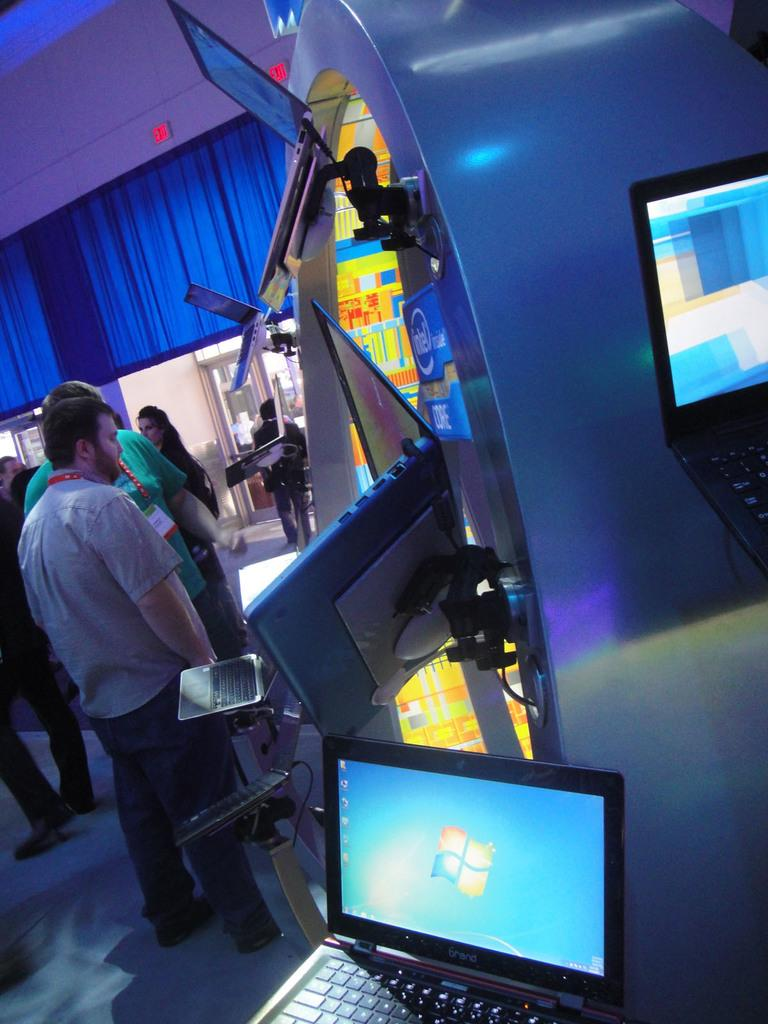What type of electronic devices are present in the image? There are laptops with stands in the image. Can you describe the people in the image? There is a group of people standing in the image. What can be seen in the background of the image? There are objects visible in the background of the image. What type of fight is taking place in the image? There is no fight present in the image; it features laptops with stands and a group of people standing. What kind of nut can be seen being discovered in the image? There is no nut or discovery present in the image. 